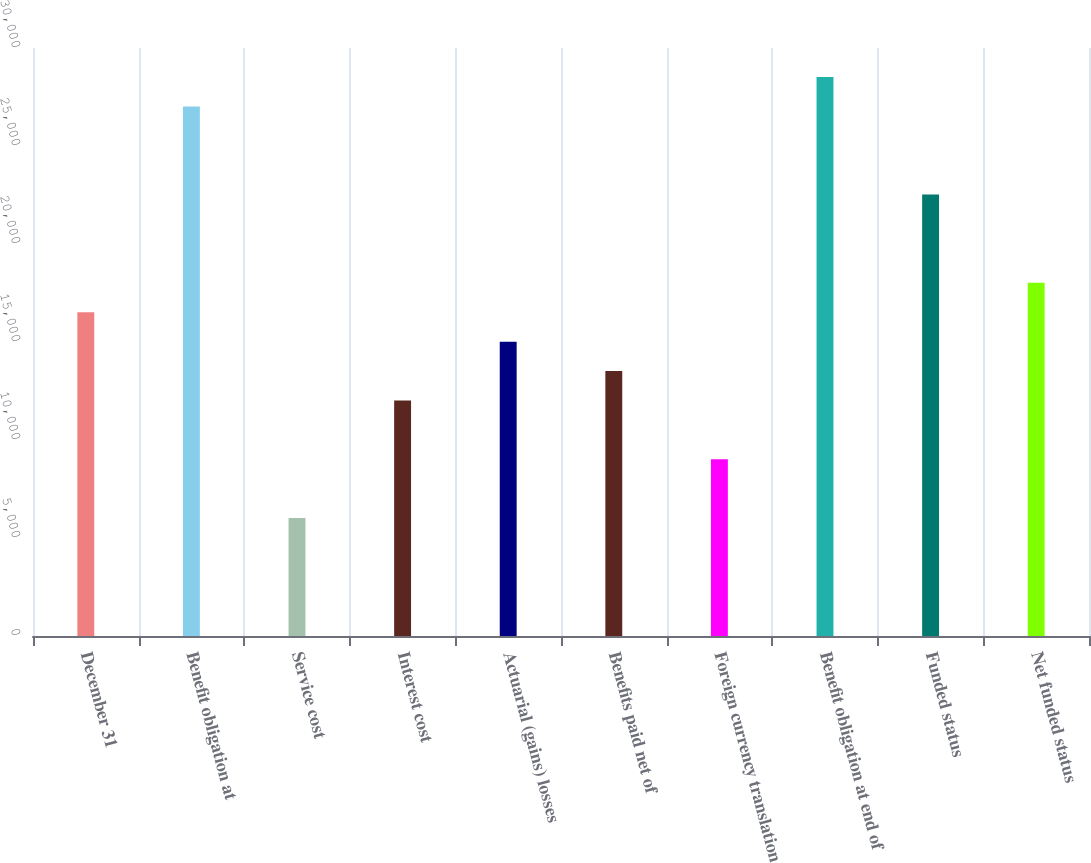Convert chart. <chart><loc_0><loc_0><loc_500><loc_500><bar_chart><fcel>December 31<fcel>Benefit obligation at<fcel>Service cost<fcel>Interest cost<fcel>Actuarial (gains) losses<fcel>Benefits paid net of<fcel>Foreign currency translation<fcel>Benefit obligation at end of<fcel>Funded status<fcel>Net funded status<nl><fcel>16519.1<fcel>27019.8<fcel>6018.4<fcel>12018.8<fcel>15019<fcel>13518.9<fcel>9018.6<fcel>28519.9<fcel>22519.5<fcel>18019.2<nl></chart> 